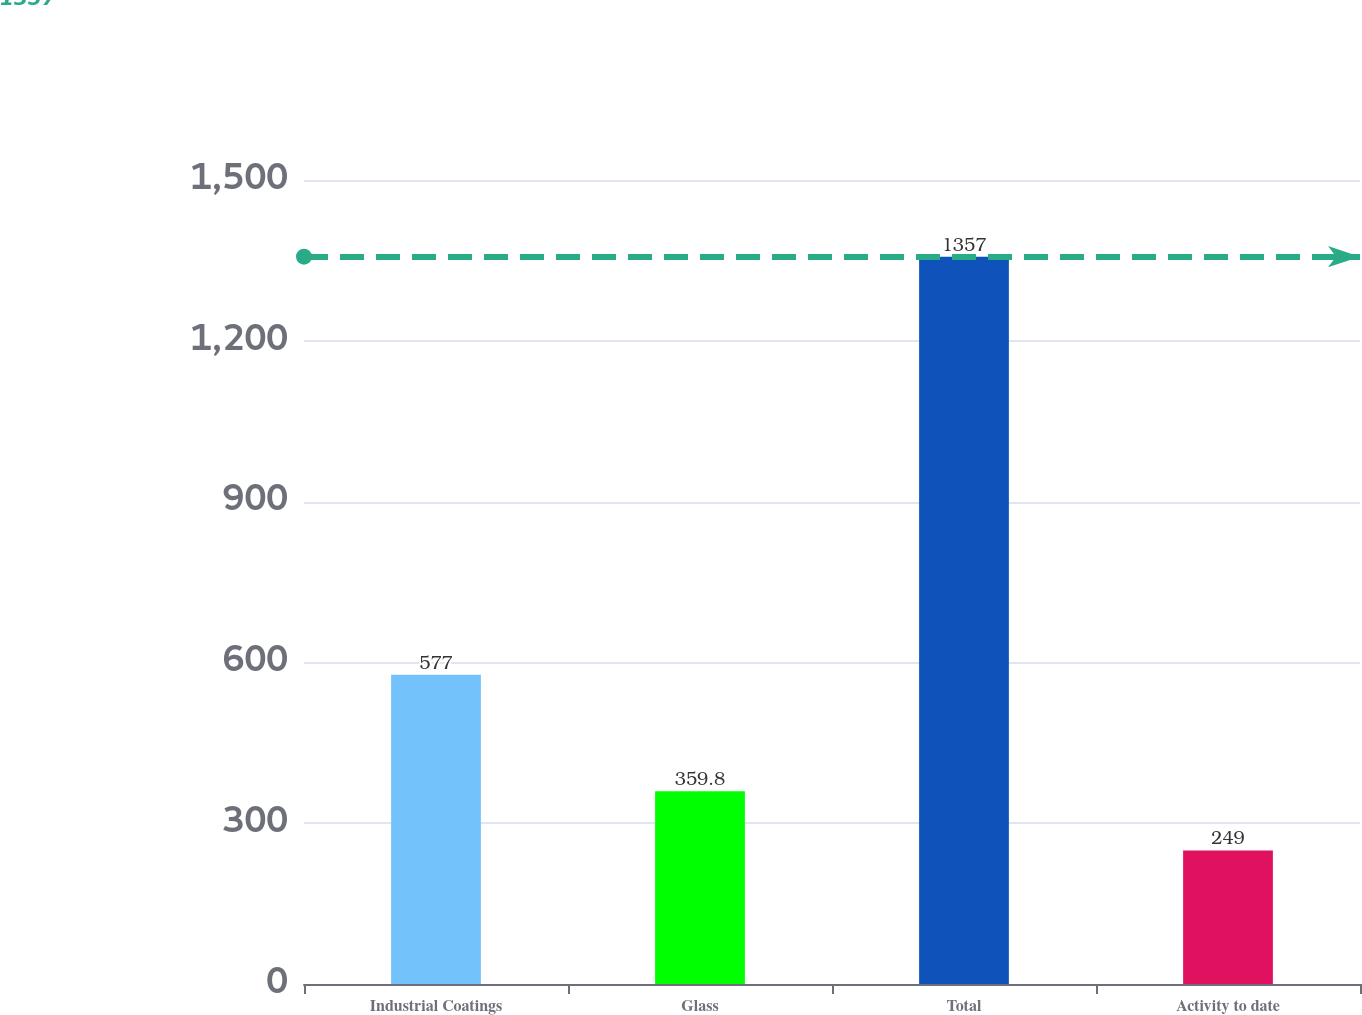Convert chart to OTSL. <chart><loc_0><loc_0><loc_500><loc_500><bar_chart><fcel>Industrial Coatings<fcel>Glass<fcel>Total<fcel>Activity to date<nl><fcel>577<fcel>359.8<fcel>1357<fcel>249<nl></chart> 